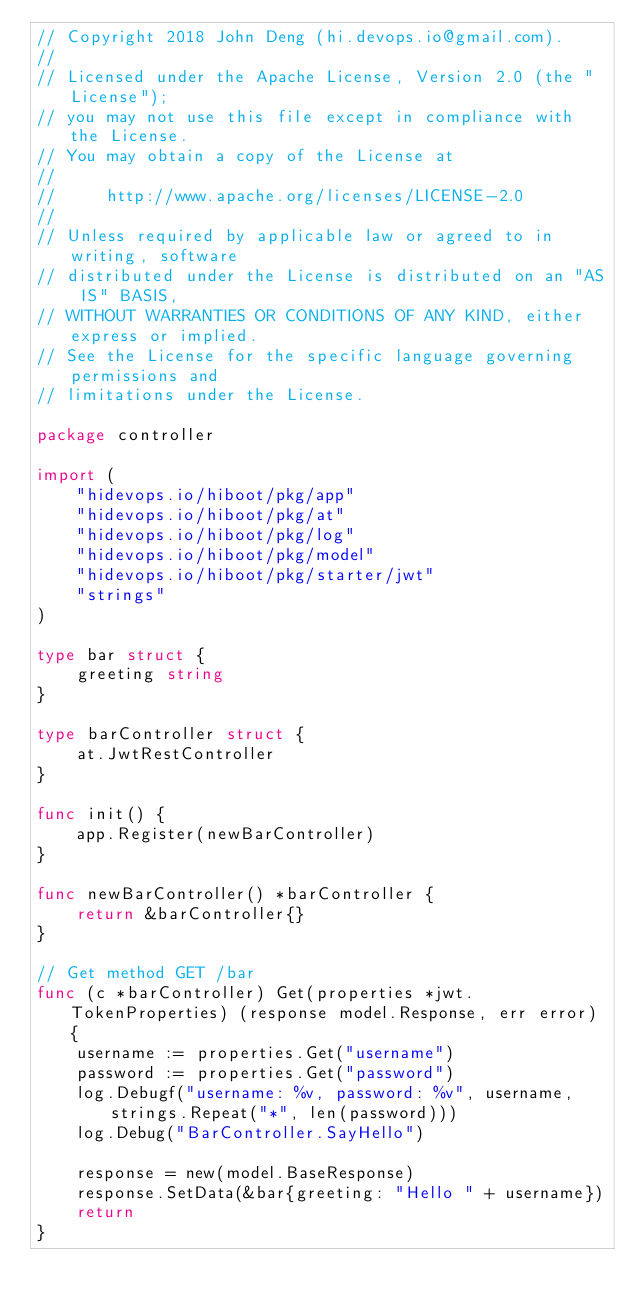<code> <loc_0><loc_0><loc_500><loc_500><_Go_>// Copyright 2018 John Deng (hi.devops.io@gmail.com).
//
// Licensed under the Apache License, Version 2.0 (the "License");
// you may not use this file except in compliance with the License.
// You may obtain a copy of the License at
//
//     http://www.apache.org/licenses/LICENSE-2.0
//
// Unless required by applicable law or agreed to in writing, software
// distributed under the License is distributed on an "AS IS" BASIS,
// WITHOUT WARRANTIES OR CONDITIONS OF ANY KIND, either express or implied.
// See the License for the specific language governing permissions and
// limitations under the License.

package controller

import (
	"hidevops.io/hiboot/pkg/app"
	"hidevops.io/hiboot/pkg/at"
	"hidevops.io/hiboot/pkg/log"
	"hidevops.io/hiboot/pkg/model"
	"hidevops.io/hiboot/pkg/starter/jwt"
	"strings"
)

type bar struct {
	greeting string
}

type barController struct {
	at.JwtRestController
}

func init() {
	app.Register(newBarController)
}

func newBarController() *barController {
	return &barController{}
}

// Get method GET /bar
func (c *barController) Get(properties *jwt.TokenProperties) (response model.Response, err error) {
	username := properties.Get("username")
	password := properties.Get("password")
	log.Debugf("username: %v, password: %v", username, strings.Repeat("*", len(password)))
	log.Debug("BarController.SayHello")

	response = new(model.BaseResponse)
	response.SetData(&bar{greeting: "Hello " + username})
	return
}
</code> 